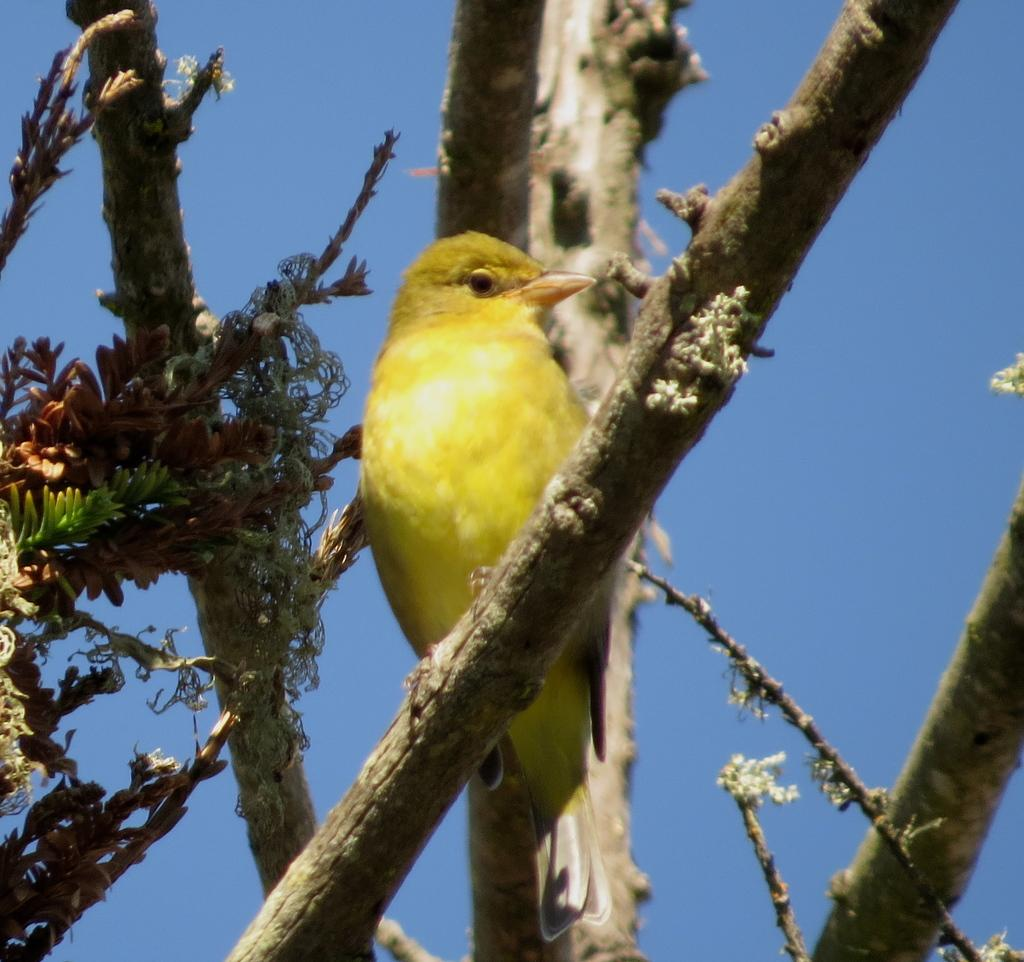What type of animal can be seen in the image? There is a bird in the image. Where is the bird located? The bird is sitting on a tree. What color is the bird? The bird is yellow in color. What can be seen in the background of the image? There is a sky visible in the background of the image. What type of paint is being used by the bird in the image? There is no paint or painting activity depicted in the image; the bird is simply sitting on a tree. 